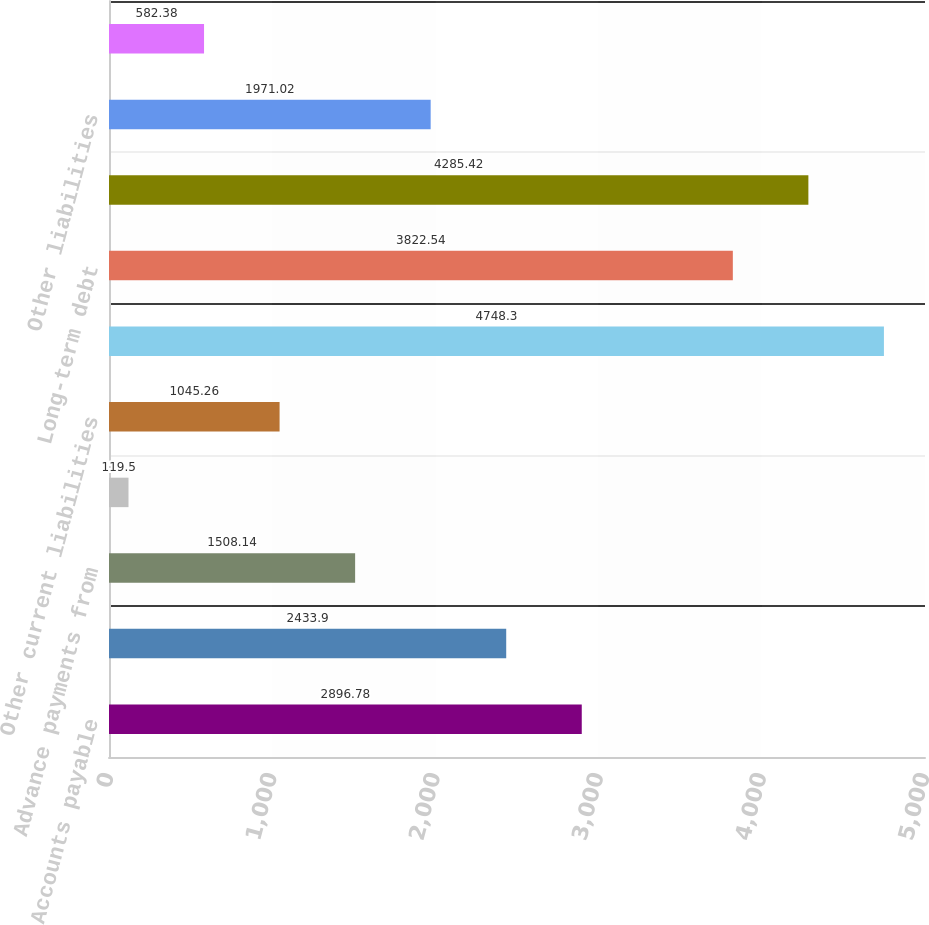<chart> <loc_0><loc_0><loc_500><loc_500><bar_chart><fcel>Accounts payable<fcel>Compensation and benefits<fcel>Advance payments from<fcel>Customer returns rebates and<fcel>Other current liabilities<fcel>Total current liabilities<fcel>Long-term debt<fcel>Retirement benefits<fcel>Other liabilities<fcel>Common stock (shares issued<nl><fcel>2896.78<fcel>2433.9<fcel>1508.14<fcel>119.5<fcel>1045.26<fcel>4748.3<fcel>3822.54<fcel>4285.42<fcel>1971.02<fcel>582.38<nl></chart> 